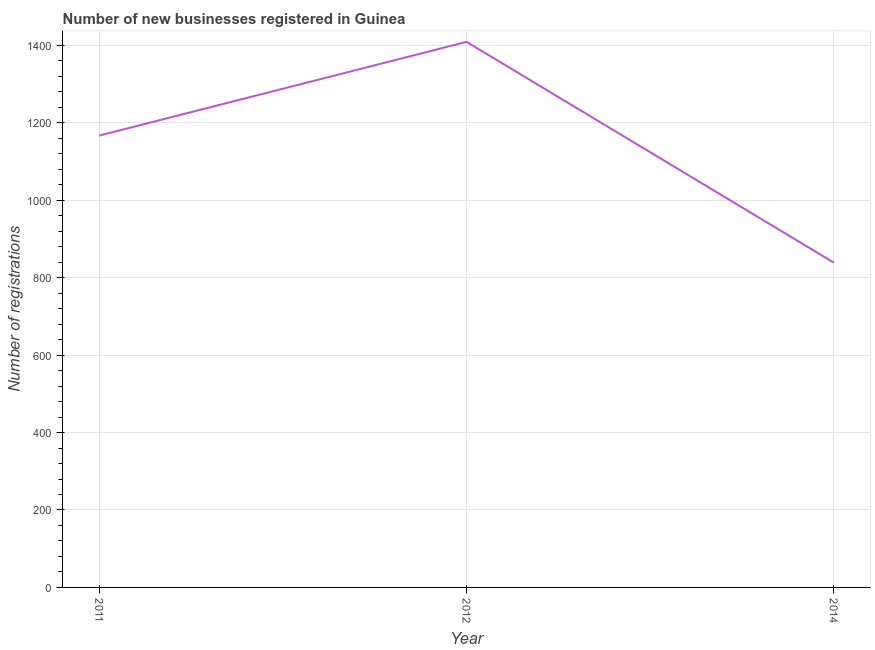What is the number of new business registrations in 2011?
Offer a terse response. 1167. Across all years, what is the maximum number of new business registrations?
Provide a short and direct response. 1409. Across all years, what is the minimum number of new business registrations?
Provide a short and direct response. 839. What is the sum of the number of new business registrations?
Offer a very short reply. 3415. What is the difference between the number of new business registrations in 2012 and 2014?
Ensure brevity in your answer.  570. What is the average number of new business registrations per year?
Offer a terse response. 1138.33. What is the median number of new business registrations?
Keep it short and to the point. 1167. In how many years, is the number of new business registrations greater than 1360 ?
Your response must be concise. 1. Do a majority of the years between 2011 and 2014 (inclusive) have number of new business registrations greater than 40 ?
Provide a succinct answer. Yes. What is the ratio of the number of new business registrations in 2011 to that in 2014?
Provide a succinct answer. 1.39. What is the difference between the highest and the second highest number of new business registrations?
Your answer should be very brief. 242. Is the sum of the number of new business registrations in 2012 and 2014 greater than the maximum number of new business registrations across all years?
Offer a terse response. Yes. What is the difference between the highest and the lowest number of new business registrations?
Give a very brief answer. 570. Does the number of new business registrations monotonically increase over the years?
Provide a succinct answer. No. How many lines are there?
Ensure brevity in your answer.  1. How many years are there in the graph?
Provide a short and direct response. 3. Are the values on the major ticks of Y-axis written in scientific E-notation?
Your answer should be very brief. No. Does the graph contain grids?
Provide a short and direct response. Yes. What is the title of the graph?
Provide a succinct answer. Number of new businesses registered in Guinea. What is the label or title of the Y-axis?
Offer a very short reply. Number of registrations. What is the Number of registrations of 2011?
Your answer should be very brief. 1167. What is the Number of registrations in 2012?
Provide a succinct answer. 1409. What is the Number of registrations in 2014?
Provide a succinct answer. 839. What is the difference between the Number of registrations in 2011 and 2012?
Give a very brief answer. -242. What is the difference between the Number of registrations in 2011 and 2014?
Provide a short and direct response. 328. What is the difference between the Number of registrations in 2012 and 2014?
Your answer should be compact. 570. What is the ratio of the Number of registrations in 2011 to that in 2012?
Offer a very short reply. 0.83. What is the ratio of the Number of registrations in 2011 to that in 2014?
Give a very brief answer. 1.39. What is the ratio of the Number of registrations in 2012 to that in 2014?
Provide a short and direct response. 1.68. 